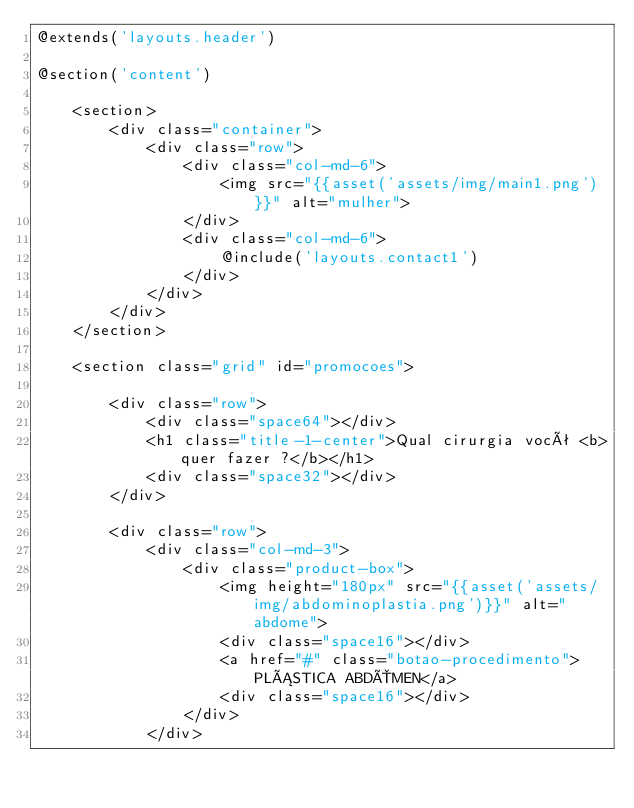Convert code to text. <code><loc_0><loc_0><loc_500><loc_500><_PHP_>@extends('layouts.header')

@section('content')

    <section>
        <div class="container">
            <div class="row">
                <div class="col-md-6">
                    <img src="{{asset('assets/img/main1.png')}}" alt="mulher">
                </div>
                <div class="col-md-6">
                    @include('layouts.contact1')
                </div>
            </div>
        </div>
    </section>

    <section class="grid" id="promocoes">

        <div class="row">
            <div class="space64"></div>
            <h1 class="title-1-center">Qual cirurgia você <b>quer fazer ?</b></h1>
            <div class="space32"></div>
        </div>
        
        <div class="row">
            <div class="col-md-3">
                <div class="product-box">
                    <img height="180px" src="{{asset('assets/img/abdominoplastia.png')}}" alt="abdome">
                    <div class="space16"></div>
                    <a href="#" class="botao-procedimento">PLÁSTICA ABDÔMEN</a>
                    <div class="space16"></div>
                </div>
            </div></code> 